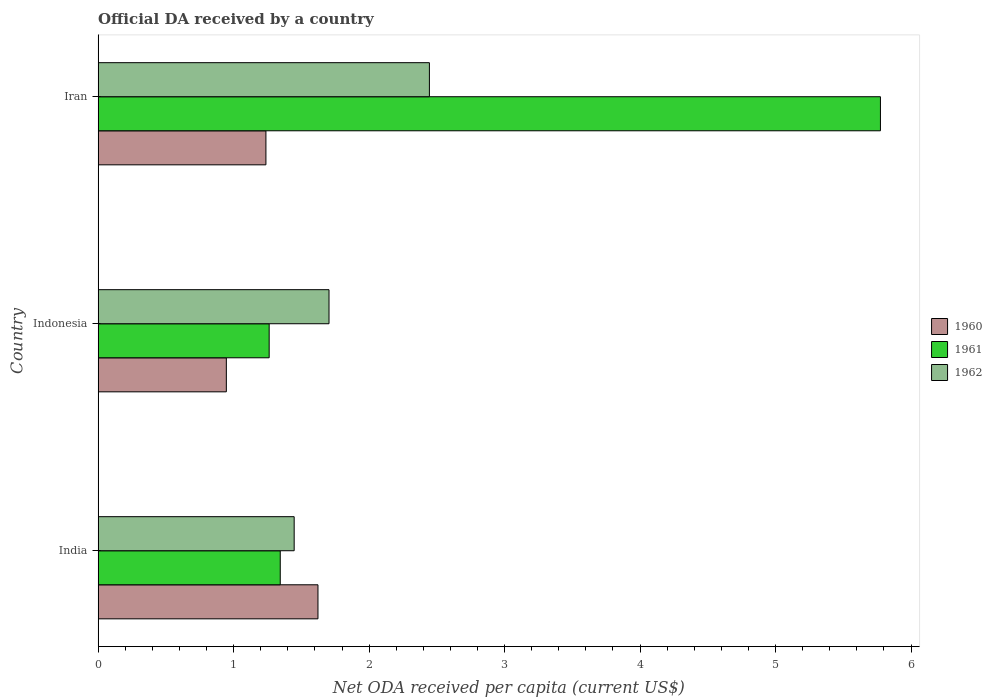How many groups of bars are there?
Provide a short and direct response. 3. Are the number of bars per tick equal to the number of legend labels?
Ensure brevity in your answer.  Yes. How many bars are there on the 3rd tick from the bottom?
Make the answer very short. 3. What is the ODA received in in 1962 in Iran?
Give a very brief answer. 2.45. Across all countries, what is the maximum ODA received in in 1961?
Ensure brevity in your answer.  5.77. Across all countries, what is the minimum ODA received in in 1961?
Keep it short and to the point. 1.26. In which country was the ODA received in in 1961 maximum?
Make the answer very short. Iran. In which country was the ODA received in in 1960 minimum?
Offer a terse response. Indonesia. What is the total ODA received in in 1962 in the graph?
Provide a succinct answer. 5.6. What is the difference between the ODA received in in 1961 in Indonesia and that in Iran?
Your response must be concise. -4.51. What is the difference between the ODA received in in 1960 in India and the ODA received in in 1961 in Iran?
Keep it short and to the point. -4.15. What is the average ODA received in in 1961 per country?
Make the answer very short. 2.79. What is the difference between the ODA received in in 1961 and ODA received in in 1960 in Indonesia?
Your answer should be very brief. 0.32. In how many countries, is the ODA received in in 1961 greater than 3 US$?
Give a very brief answer. 1. What is the ratio of the ODA received in in 1960 in India to that in Iran?
Offer a terse response. 1.31. Is the difference between the ODA received in in 1961 in India and Iran greater than the difference between the ODA received in in 1960 in India and Iran?
Offer a very short reply. No. What is the difference between the highest and the second highest ODA received in in 1962?
Your response must be concise. 0.74. What is the difference between the highest and the lowest ODA received in in 1961?
Keep it short and to the point. 4.51. In how many countries, is the ODA received in in 1961 greater than the average ODA received in in 1961 taken over all countries?
Provide a short and direct response. 1. Is the sum of the ODA received in in 1962 in India and Iran greater than the maximum ODA received in in 1960 across all countries?
Provide a short and direct response. Yes. Are all the bars in the graph horizontal?
Make the answer very short. Yes. How many countries are there in the graph?
Make the answer very short. 3. Does the graph contain grids?
Provide a succinct answer. No. Where does the legend appear in the graph?
Make the answer very short. Center right. How many legend labels are there?
Keep it short and to the point. 3. What is the title of the graph?
Offer a terse response. Official DA received by a country. What is the label or title of the X-axis?
Your answer should be very brief. Net ODA received per capita (current US$). What is the label or title of the Y-axis?
Ensure brevity in your answer.  Country. What is the Net ODA received per capita (current US$) in 1960 in India?
Offer a very short reply. 1.62. What is the Net ODA received per capita (current US$) of 1961 in India?
Provide a succinct answer. 1.34. What is the Net ODA received per capita (current US$) in 1962 in India?
Your answer should be compact. 1.45. What is the Net ODA received per capita (current US$) of 1960 in Indonesia?
Provide a succinct answer. 0.95. What is the Net ODA received per capita (current US$) in 1961 in Indonesia?
Provide a short and direct response. 1.26. What is the Net ODA received per capita (current US$) of 1962 in Indonesia?
Your answer should be very brief. 1.7. What is the Net ODA received per capita (current US$) in 1960 in Iran?
Your response must be concise. 1.24. What is the Net ODA received per capita (current US$) of 1961 in Iran?
Offer a very short reply. 5.77. What is the Net ODA received per capita (current US$) in 1962 in Iran?
Ensure brevity in your answer.  2.45. Across all countries, what is the maximum Net ODA received per capita (current US$) in 1960?
Offer a very short reply. 1.62. Across all countries, what is the maximum Net ODA received per capita (current US$) of 1961?
Your answer should be very brief. 5.77. Across all countries, what is the maximum Net ODA received per capita (current US$) of 1962?
Ensure brevity in your answer.  2.45. Across all countries, what is the minimum Net ODA received per capita (current US$) in 1960?
Your response must be concise. 0.95. Across all countries, what is the minimum Net ODA received per capita (current US$) in 1961?
Your answer should be very brief. 1.26. Across all countries, what is the minimum Net ODA received per capita (current US$) of 1962?
Your answer should be compact. 1.45. What is the total Net ODA received per capita (current US$) in 1960 in the graph?
Provide a succinct answer. 3.81. What is the total Net ODA received per capita (current US$) of 1961 in the graph?
Ensure brevity in your answer.  8.38. What is the total Net ODA received per capita (current US$) in 1962 in the graph?
Your response must be concise. 5.6. What is the difference between the Net ODA received per capita (current US$) in 1960 in India and that in Indonesia?
Your answer should be compact. 0.68. What is the difference between the Net ODA received per capita (current US$) in 1961 in India and that in Indonesia?
Ensure brevity in your answer.  0.08. What is the difference between the Net ODA received per capita (current US$) in 1962 in India and that in Indonesia?
Ensure brevity in your answer.  -0.26. What is the difference between the Net ODA received per capita (current US$) in 1960 in India and that in Iran?
Your response must be concise. 0.38. What is the difference between the Net ODA received per capita (current US$) in 1961 in India and that in Iran?
Keep it short and to the point. -4.43. What is the difference between the Net ODA received per capita (current US$) of 1962 in India and that in Iran?
Offer a very short reply. -1. What is the difference between the Net ODA received per capita (current US$) in 1960 in Indonesia and that in Iran?
Give a very brief answer. -0.29. What is the difference between the Net ODA received per capita (current US$) of 1961 in Indonesia and that in Iran?
Provide a short and direct response. -4.51. What is the difference between the Net ODA received per capita (current US$) in 1962 in Indonesia and that in Iran?
Give a very brief answer. -0.74. What is the difference between the Net ODA received per capita (current US$) of 1960 in India and the Net ODA received per capita (current US$) of 1961 in Indonesia?
Offer a very short reply. 0.36. What is the difference between the Net ODA received per capita (current US$) of 1960 in India and the Net ODA received per capita (current US$) of 1962 in Indonesia?
Offer a very short reply. -0.08. What is the difference between the Net ODA received per capita (current US$) in 1961 in India and the Net ODA received per capita (current US$) in 1962 in Indonesia?
Give a very brief answer. -0.36. What is the difference between the Net ODA received per capita (current US$) of 1960 in India and the Net ODA received per capita (current US$) of 1961 in Iran?
Your answer should be very brief. -4.15. What is the difference between the Net ODA received per capita (current US$) in 1960 in India and the Net ODA received per capita (current US$) in 1962 in Iran?
Provide a short and direct response. -0.82. What is the difference between the Net ODA received per capita (current US$) in 1961 in India and the Net ODA received per capita (current US$) in 1962 in Iran?
Your answer should be very brief. -1.1. What is the difference between the Net ODA received per capita (current US$) of 1960 in Indonesia and the Net ODA received per capita (current US$) of 1961 in Iran?
Ensure brevity in your answer.  -4.83. What is the difference between the Net ODA received per capita (current US$) in 1960 in Indonesia and the Net ODA received per capita (current US$) in 1962 in Iran?
Keep it short and to the point. -1.5. What is the difference between the Net ODA received per capita (current US$) of 1961 in Indonesia and the Net ODA received per capita (current US$) of 1962 in Iran?
Your answer should be very brief. -1.18. What is the average Net ODA received per capita (current US$) of 1960 per country?
Keep it short and to the point. 1.27. What is the average Net ODA received per capita (current US$) of 1961 per country?
Make the answer very short. 2.79. What is the average Net ODA received per capita (current US$) in 1962 per country?
Ensure brevity in your answer.  1.87. What is the difference between the Net ODA received per capita (current US$) of 1960 and Net ODA received per capita (current US$) of 1961 in India?
Make the answer very short. 0.28. What is the difference between the Net ODA received per capita (current US$) in 1960 and Net ODA received per capita (current US$) in 1962 in India?
Your response must be concise. 0.18. What is the difference between the Net ODA received per capita (current US$) in 1961 and Net ODA received per capita (current US$) in 1962 in India?
Keep it short and to the point. -0.1. What is the difference between the Net ODA received per capita (current US$) of 1960 and Net ODA received per capita (current US$) of 1961 in Indonesia?
Ensure brevity in your answer.  -0.32. What is the difference between the Net ODA received per capita (current US$) in 1960 and Net ODA received per capita (current US$) in 1962 in Indonesia?
Offer a very short reply. -0.76. What is the difference between the Net ODA received per capita (current US$) of 1961 and Net ODA received per capita (current US$) of 1962 in Indonesia?
Provide a succinct answer. -0.44. What is the difference between the Net ODA received per capita (current US$) of 1960 and Net ODA received per capita (current US$) of 1961 in Iran?
Give a very brief answer. -4.54. What is the difference between the Net ODA received per capita (current US$) of 1960 and Net ODA received per capita (current US$) of 1962 in Iran?
Provide a succinct answer. -1.21. What is the difference between the Net ODA received per capita (current US$) of 1961 and Net ODA received per capita (current US$) of 1962 in Iran?
Ensure brevity in your answer.  3.33. What is the ratio of the Net ODA received per capita (current US$) of 1960 in India to that in Indonesia?
Provide a succinct answer. 1.71. What is the ratio of the Net ODA received per capita (current US$) of 1961 in India to that in Indonesia?
Provide a succinct answer. 1.06. What is the ratio of the Net ODA received per capita (current US$) in 1962 in India to that in Indonesia?
Provide a short and direct response. 0.85. What is the ratio of the Net ODA received per capita (current US$) in 1960 in India to that in Iran?
Your answer should be very brief. 1.31. What is the ratio of the Net ODA received per capita (current US$) of 1961 in India to that in Iran?
Keep it short and to the point. 0.23. What is the ratio of the Net ODA received per capita (current US$) in 1962 in India to that in Iran?
Your response must be concise. 0.59. What is the ratio of the Net ODA received per capita (current US$) of 1960 in Indonesia to that in Iran?
Make the answer very short. 0.76. What is the ratio of the Net ODA received per capita (current US$) of 1961 in Indonesia to that in Iran?
Give a very brief answer. 0.22. What is the ratio of the Net ODA received per capita (current US$) of 1962 in Indonesia to that in Iran?
Keep it short and to the point. 0.7. What is the difference between the highest and the second highest Net ODA received per capita (current US$) of 1960?
Offer a terse response. 0.38. What is the difference between the highest and the second highest Net ODA received per capita (current US$) in 1961?
Your response must be concise. 4.43. What is the difference between the highest and the second highest Net ODA received per capita (current US$) of 1962?
Keep it short and to the point. 0.74. What is the difference between the highest and the lowest Net ODA received per capita (current US$) in 1960?
Make the answer very short. 0.68. What is the difference between the highest and the lowest Net ODA received per capita (current US$) of 1961?
Provide a short and direct response. 4.51. What is the difference between the highest and the lowest Net ODA received per capita (current US$) of 1962?
Make the answer very short. 1. 